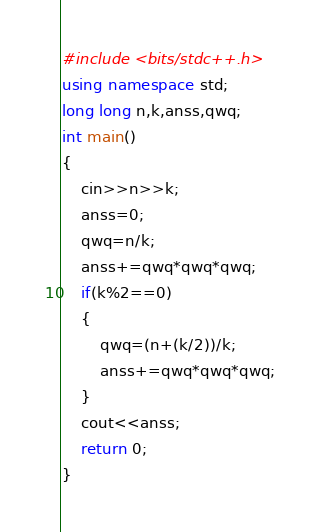<code> <loc_0><loc_0><loc_500><loc_500><_C++_>#include <bits/stdc++.h>
using namespace std;
long long n,k,anss,qwq;
int main()
{
	cin>>n>>k;
	anss=0;
	qwq=n/k;
	anss+=qwq*qwq*qwq;
	if(k%2==0)
	{
		qwq=(n+(k/2))/k;
		anss+=qwq*qwq*qwq;
	}
	cout<<anss;
	return 0;
} </code> 